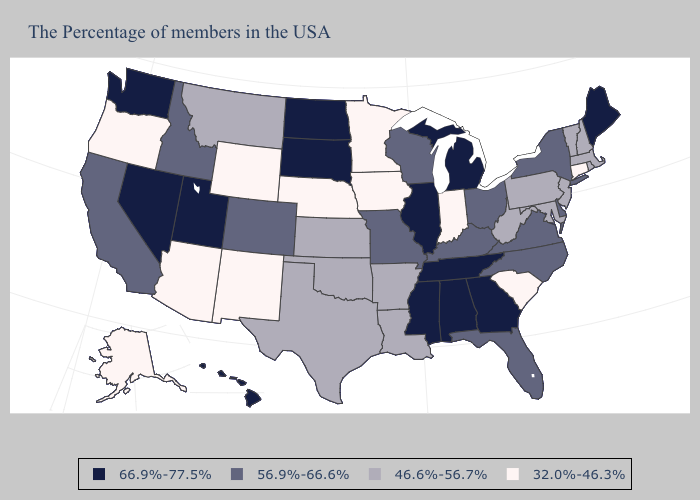Does the map have missing data?
Quick response, please. No. How many symbols are there in the legend?
Give a very brief answer. 4. What is the highest value in the West ?
Give a very brief answer. 66.9%-77.5%. Does Connecticut have the lowest value in the Northeast?
Keep it brief. Yes. Which states have the lowest value in the USA?
Write a very short answer. Connecticut, South Carolina, Indiana, Minnesota, Iowa, Nebraska, Wyoming, New Mexico, Arizona, Oregon, Alaska. What is the value of Virginia?
Quick response, please. 56.9%-66.6%. Name the states that have a value in the range 66.9%-77.5%?
Answer briefly. Maine, Georgia, Michigan, Alabama, Tennessee, Illinois, Mississippi, South Dakota, North Dakota, Utah, Nevada, Washington, Hawaii. What is the value of Illinois?
Be succinct. 66.9%-77.5%. Name the states that have a value in the range 32.0%-46.3%?
Concise answer only. Connecticut, South Carolina, Indiana, Minnesota, Iowa, Nebraska, Wyoming, New Mexico, Arizona, Oregon, Alaska. What is the value of New Hampshire?
Write a very short answer. 46.6%-56.7%. Name the states that have a value in the range 46.6%-56.7%?
Concise answer only. Massachusetts, Rhode Island, New Hampshire, Vermont, New Jersey, Maryland, Pennsylvania, West Virginia, Louisiana, Arkansas, Kansas, Oklahoma, Texas, Montana. Does Louisiana have the highest value in the USA?
Keep it brief. No. Does the first symbol in the legend represent the smallest category?
Give a very brief answer. No. Does California have the lowest value in the USA?
Give a very brief answer. No. 